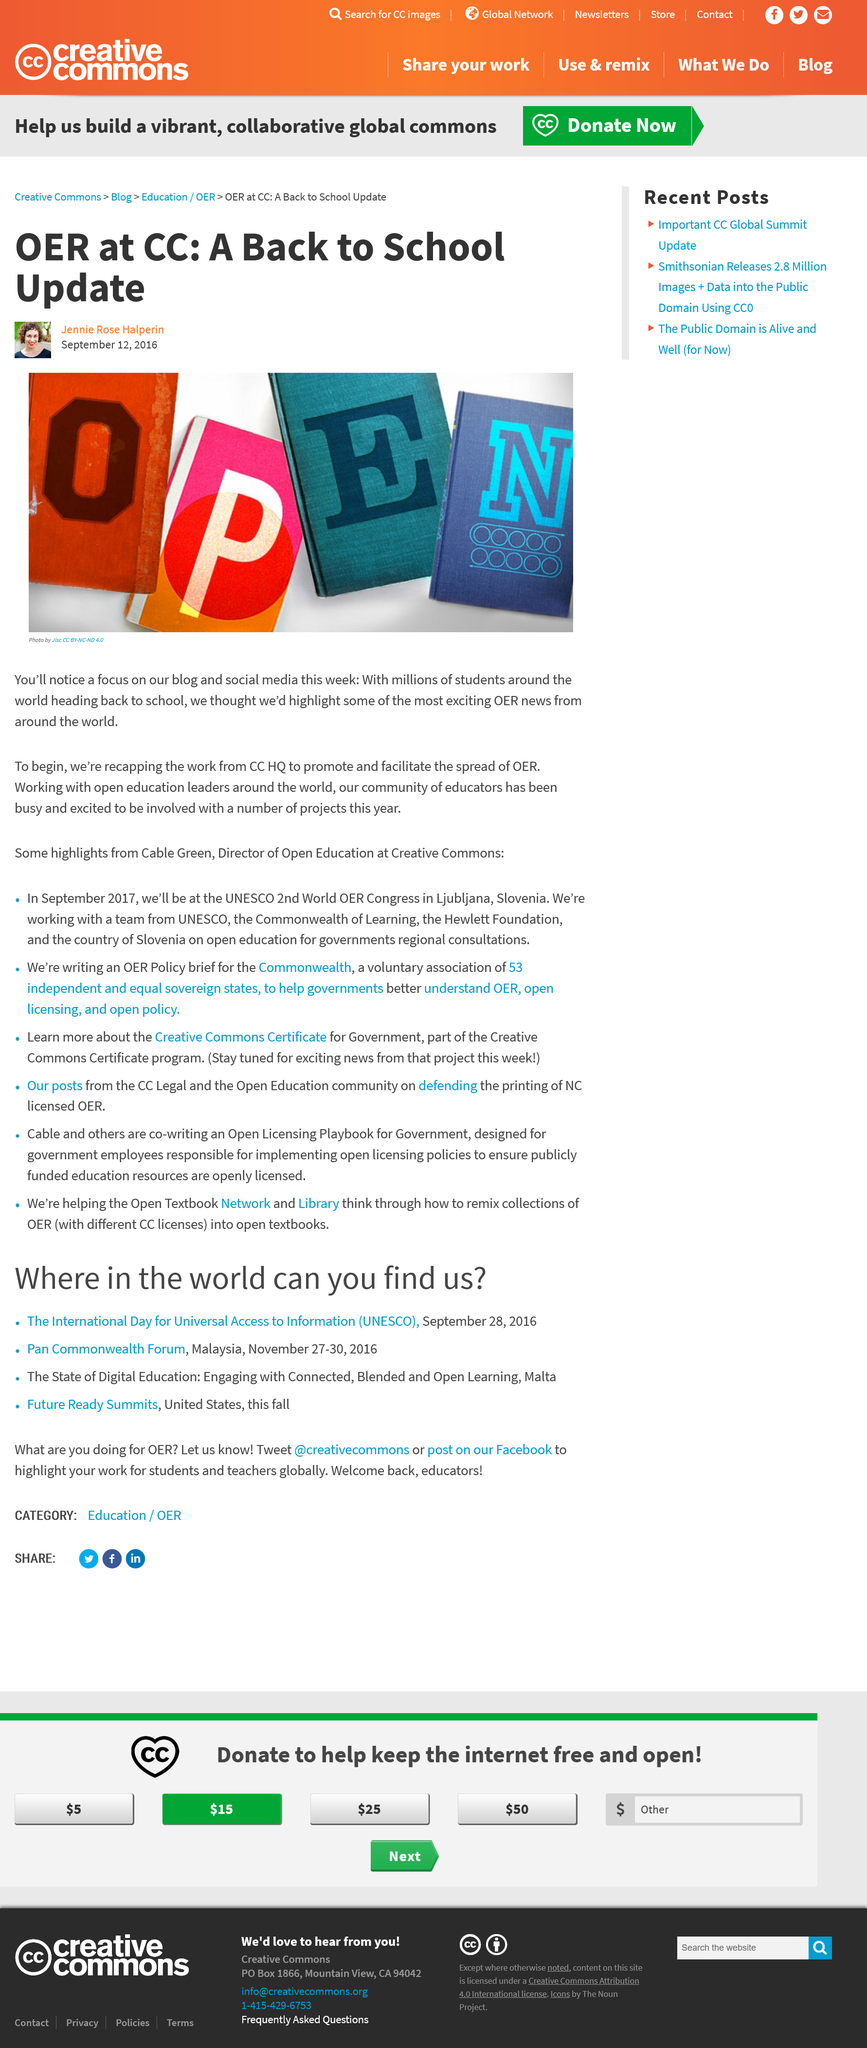Outline some significant characteristics in this image. The publish date of the text is September 12, 2016. CC HQ is promoting the promotion and facilitation of the spread of Open Educational Resources (OER). The image titled "OPEN" is the copyright of Jisc and is licensed under the Creative Commons Attribution-NonCommercial-NoDerivatives 4.0 license. 